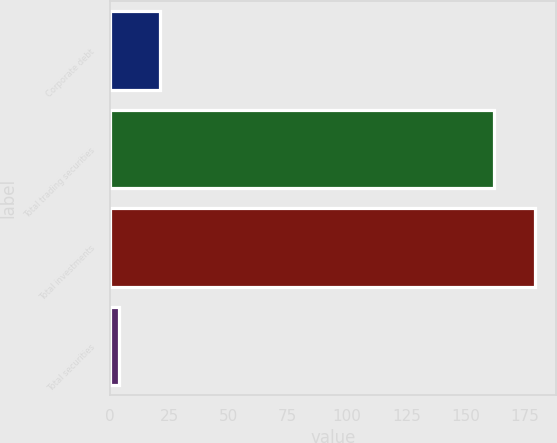<chart> <loc_0><loc_0><loc_500><loc_500><bar_chart><fcel>Corporate debt<fcel>Total trading securities<fcel>Total investments<fcel>Total securities<nl><fcel>21.1<fcel>162<fcel>179.1<fcel>4<nl></chart> 